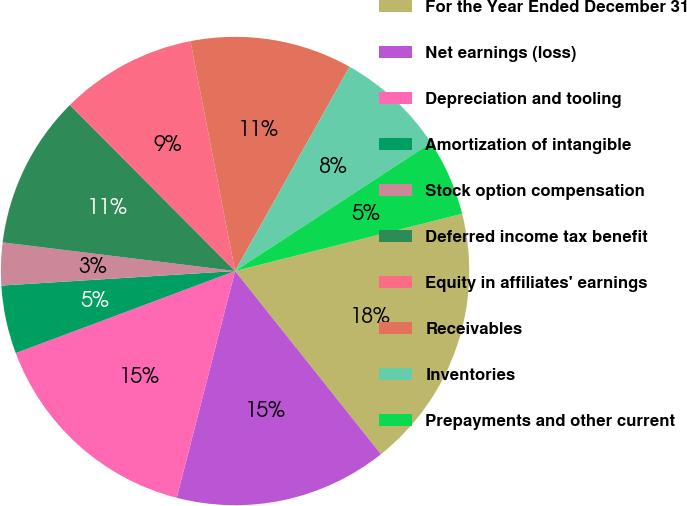<chart> <loc_0><loc_0><loc_500><loc_500><pie_chart><fcel>For the Year Ended December 31<fcel>Net earnings (loss)<fcel>Depreciation and tooling<fcel>Amortization of intangible<fcel>Stock option compensation<fcel>Deferred income tax benefit<fcel>Equity in affiliates' earnings<fcel>Receivables<fcel>Inventories<fcel>Prepayments and other current<nl><fcel>18.23%<fcel>14.71%<fcel>15.29%<fcel>4.71%<fcel>2.94%<fcel>10.59%<fcel>9.41%<fcel>11.18%<fcel>7.65%<fcel>5.29%<nl></chart> 